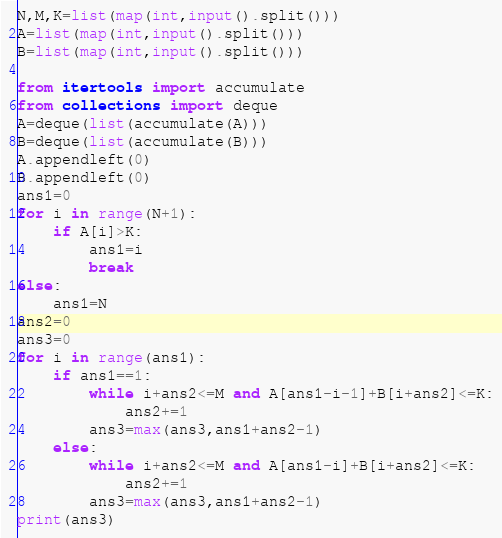<code> <loc_0><loc_0><loc_500><loc_500><_Python_>N,M,K=list(map(int,input().split()))
A=list(map(int,input().split()))
B=list(map(int,input().split()))

from itertools import accumulate
from collections import deque
A=deque(list(accumulate(A)))
B=deque(list(accumulate(B)))
A.appendleft(0)
B.appendleft(0)
ans1=0
for i in range(N+1):
    if A[i]>K:
        ans1=i
        break
else:
    ans1=N
ans2=0
ans3=0
for i in range(ans1):
    if ans1==1:
        while i+ans2<=M and A[ans1-i-1]+B[i+ans2]<=K:
            ans2+=1
        ans3=max(ans3,ans1+ans2-1)
    else:
        while i+ans2<=M and A[ans1-i]+B[i+ans2]<=K:
            ans2+=1
        ans3=max(ans3,ans1+ans2-1)
print(ans3)</code> 